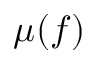<formula> <loc_0><loc_0><loc_500><loc_500>\mu ( f )</formula> 